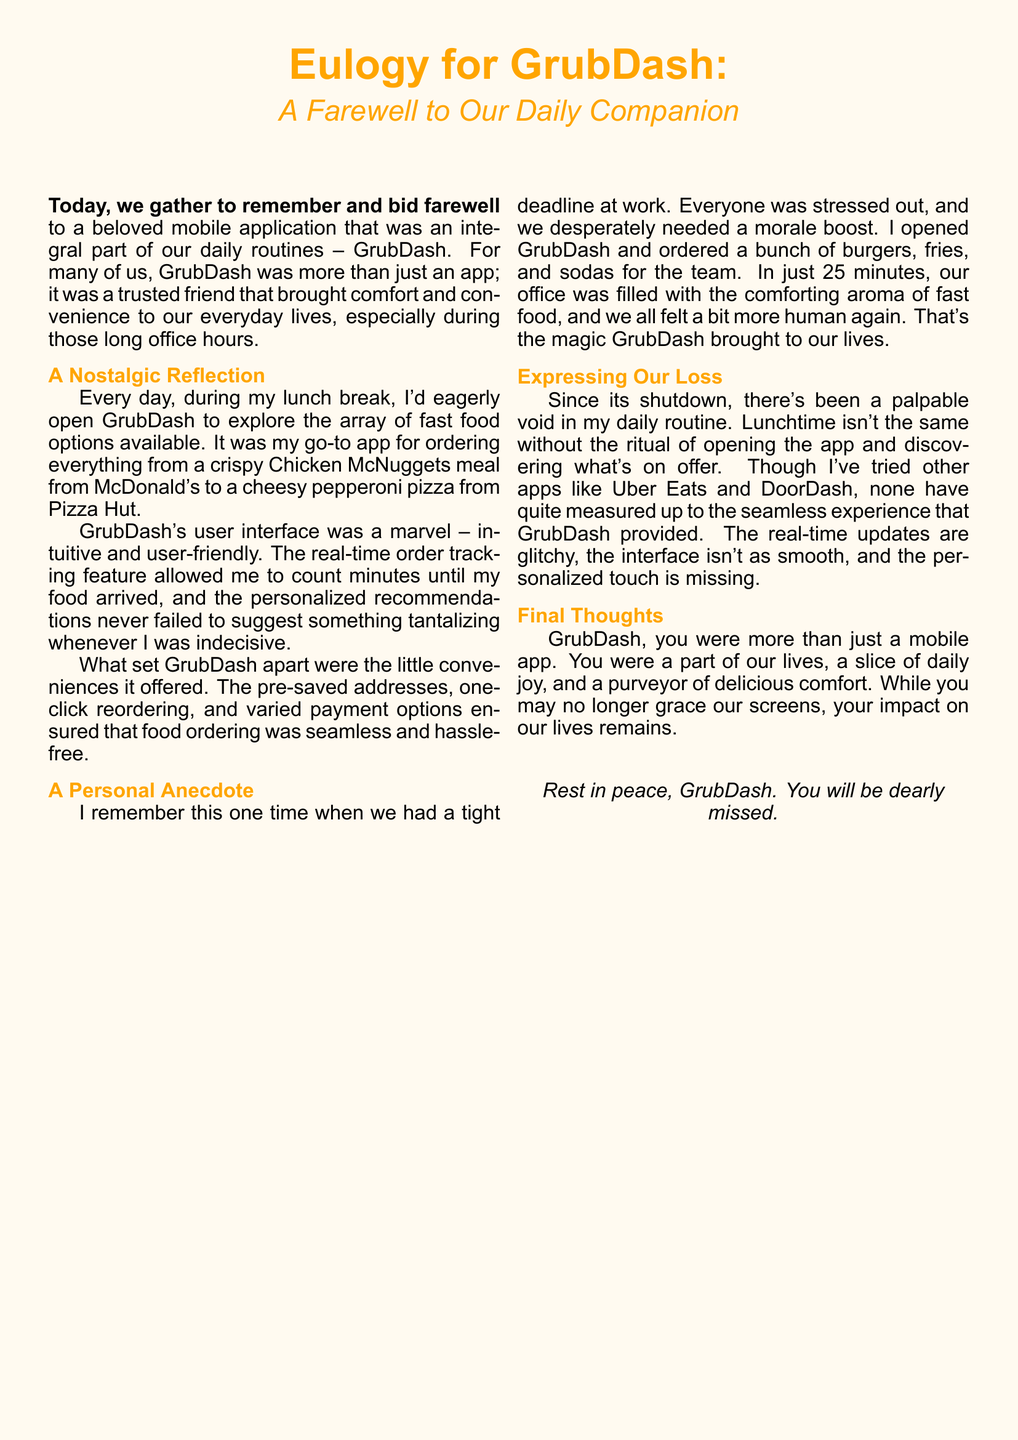What is the name of the mobile app being remembered? The app being remembered is GrubDash.
Answer: GrubDash What type of food did the user order for the team during a tight deadline? The user ordered burgers, fries, and sodas.
Answer: Burgers, fries, and sodas Which feature of GrubDash allowed users to track their orders? The feature that allowed order tracking was real-time order tracking.
Answer: Real-time order tracking What color is associated with the eulogy document? The color associated with the document is orange.
Answer: Orange How many minutes did it take for the food to arrive when ordered for the team? It took 25 minutes for the food to arrive.
Answer: 25 minutes What is expressed as a feeling due to the app's shutdown? The document expresses a palpable void in daily routine.
Answer: Palpable void Which other apps did the user try after GrubDash? The user tried Uber Eats and DoorDash.
Answer: Uber Eats and DoorDash What does the eulogy say GrubDash provided that other apps lack? GrubDash provided a seamless experience.
Answer: Seamless experience What emotion does the eulogy convey towards GrubDash? The emotion conveyed towards GrubDash is nostalgia.
Answer: Nostalgia 